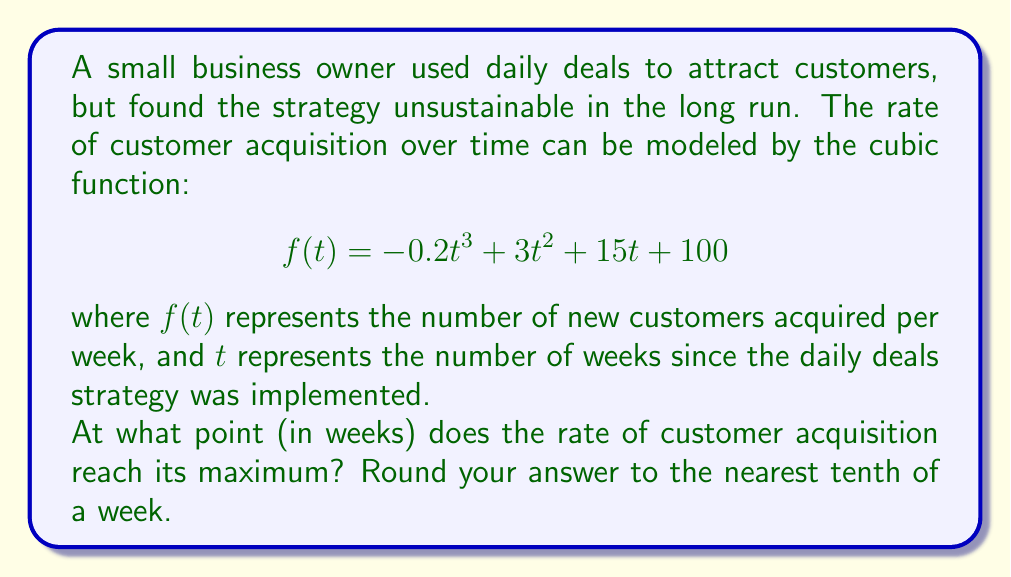Give your solution to this math problem. To find the maximum point of the cubic function, we need to follow these steps:

1) Find the derivative of the function:
   $$f'(t) = -0.6t^2 + 6t + 15$$

2) Set the derivative equal to zero and solve for t:
   $$-0.6t^2 + 6t + 15 = 0$$

3) This is a quadratic equation. We can solve it using the quadratic formula:
   $$t = \frac{-b \pm \sqrt{b^2 - 4ac}}{2a}$$
   where $a = -0.6$, $b = 6$, and $c = 15$

4) Substituting these values:
   $$t = \frac{-6 \pm \sqrt{6^2 - 4(-0.6)(15)}}{2(-0.6)}$$
   $$= \frac{-6 \pm \sqrt{36 + 36}}{-1.2}$$
   $$= \frac{-6 \pm \sqrt{72}}{-1.2}$$
   $$= \frac{-6 \pm 8.485}{-1.2}$$

5) This gives us two solutions:
   $$t_1 = \frac{-6 + 8.485}{-1.2} \approx 2.071$$
   $$t_2 = \frac{-6 - 8.485}{-1.2} \approx 12.071$$

6) To determine which solution gives the maximum, we can check the second derivative:
   $$f''(t) = -1.2t + 6$$

7) At $t = 2.071$: $f''(2.071) \approx -2.485 < 0$, indicating a maximum.
   At $t = 12.071$: $f''(12.071) \approx -8.485 < 0$, indicating a maximum.

8) Since both points are maxima, we need to compare the function values:
   $f(2.071) \approx 137.6$
   $f(12.071) \approx 129.6$

Therefore, the maximum occurs at $t \approx 2.071$ weeks.

Rounding to the nearest tenth of a week gives us 2.1 weeks.
Answer: 2.1 weeks 